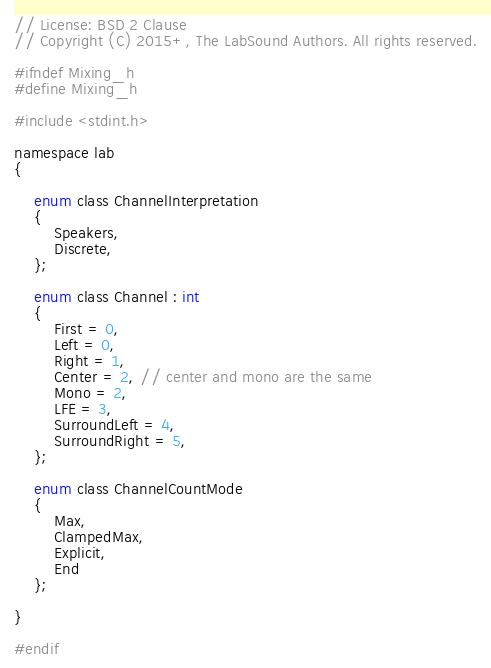<code> <loc_0><loc_0><loc_500><loc_500><_C_>// License: BSD 2 Clause
// Copyright (C) 2015+, The LabSound Authors. All rights reserved.

#ifndef Mixing_h
#define Mixing_h

#include <stdint.h>

namespace lab
{
    
    enum class ChannelInterpretation
    {
        Speakers,
        Discrete,
    };
    
    enum class Channel : int
    {
        First = 0,
        Left = 0,
        Right = 1,
        Center = 2, // center and mono are the same
        Mono = 2,
        LFE = 3,
        SurroundLeft = 4,
        SurroundRight = 5,
    };
    
    enum class ChannelCountMode
    {
        Max,
        ClampedMax,
        Explicit,
        End
    };

}

#endif
</code> 